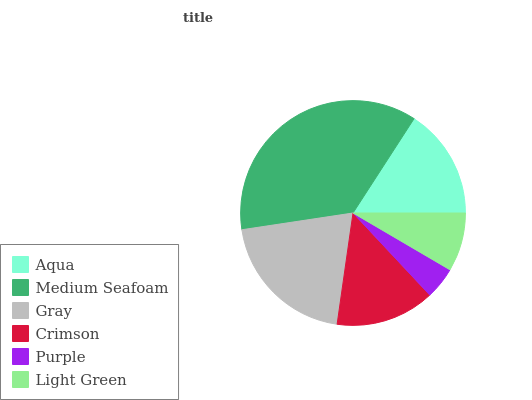Is Purple the minimum?
Answer yes or no. Yes. Is Medium Seafoam the maximum?
Answer yes or no. Yes. Is Gray the minimum?
Answer yes or no. No. Is Gray the maximum?
Answer yes or no. No. Is Medium Seafoam greater than Gray?
Answer yes or no. Yes. Is Gray less than Medium Seafoam?
Answer yes or no. Yes. Is Gray greater than Medium Seafoam?
Answer yes or no. No. Is Medium Seafoam less than Gray?
Answer yes or no. No. Is Aqua the high median?
Answer yes or no. Yes. Is Crimson the low median?
Answer yes or no. Yes. Is Crimson the high median?
Answer yes or no. No. Is Purple the low median?
Answer yes or no. No. 